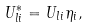Convert formula to latex. <formula><loc_0><loc_0><loc_500><loc_500>U ^ { * } _ { l i } = U _ { l i } \eta _ { i } ,</formula> 